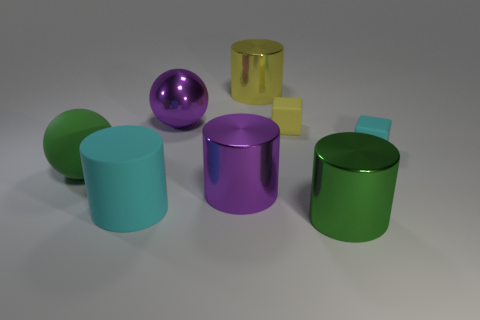Is the color of the big sphere behind the green rubber ball the same as the large metallic cylinder left of the yellow metallic cylinder?
Ensure brevity in your answer.  Yes. What size is the metal thing that is the same color as the big metallic ball?
Offer a terse response. Large. Are there an equal number of yellow objects that are right of the yellow rubber object and big yellow things that are behind the large purple shiny sphere?
Offer a very short reply. No. Are there any purple things left of the large purple ball?
Your response must be concise. No. There is a shiny cylinder that is behind the purple shiny cylinder; what is its color?
Offer a very short reply. Yellow. What material is the large green object that is left of the large metal cylinder in front of the purple shiny cylinder?
Make the answer very short. Rubber. Are there fewer green things that are on the right side of the purple cylinder than rubber things left of the yellow matte thing?
Make the answer very short. Yes. How many yellow objects are big metallic spheres or tiny matte cubes?
Provide a succinct answer. 1. Are there an equal number of metal things that are on the right side of the shiny sphere and large shiny cylinders?
Make the answer very short. Yes. What number of things are either big cyan matte objects or cyan rubber things that are in front of the yellow metal object?
Make the answer very short. 2. 